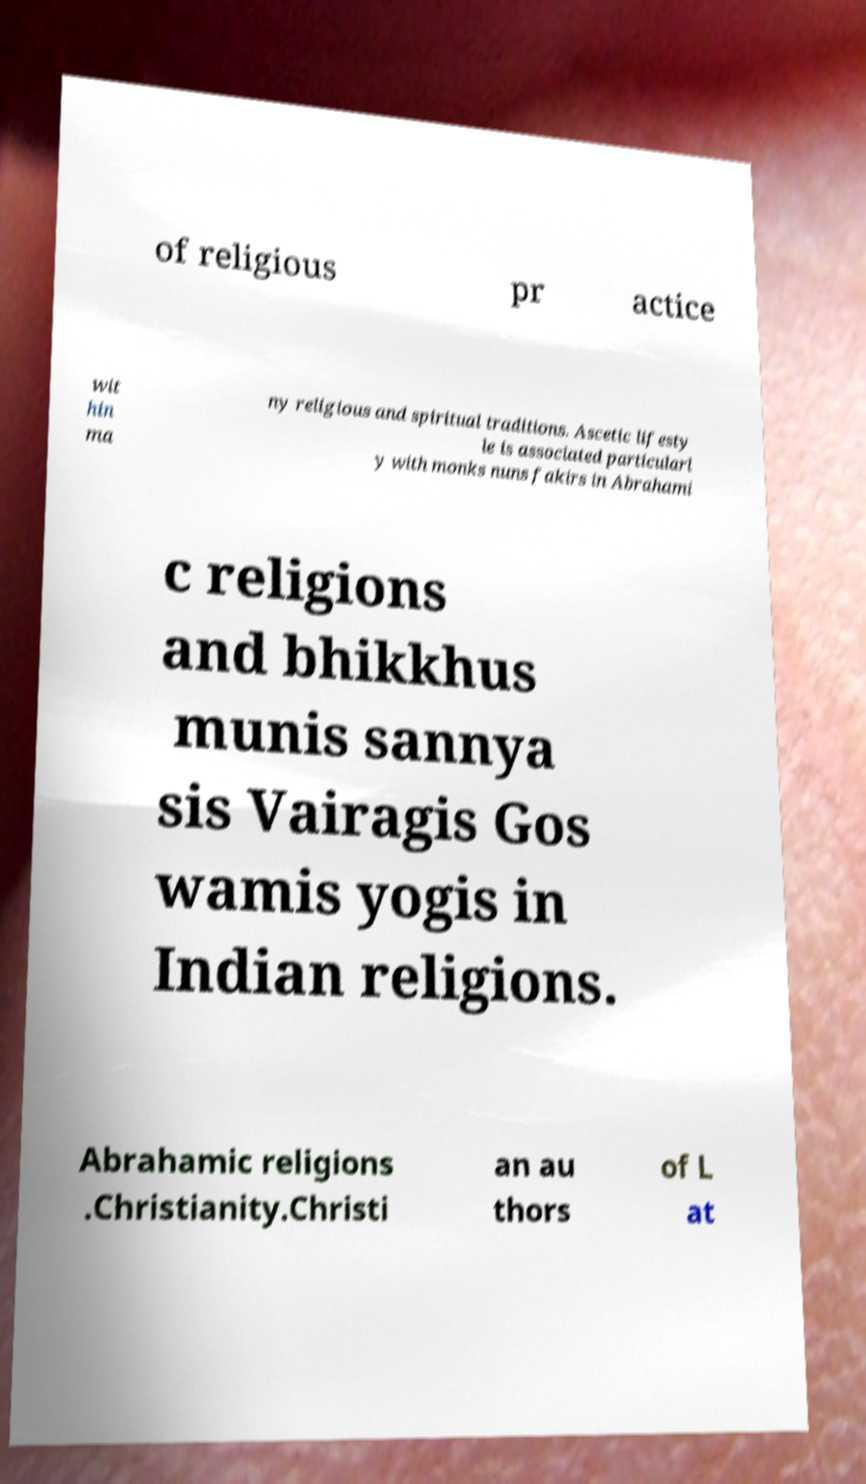Please identify and transcribe the text found in this image. of religious pr actice wit hin ma ny religious and spiritual traditions. Ascetic lifesty le is associated particularl y with monks nuns fakirs in Abrahami c religions and bhikkhus munis sannya sis Vairagis Gos wamis yogis in Indian religions. Abrahamic religions .Christianity.Christi an au thors of L at 